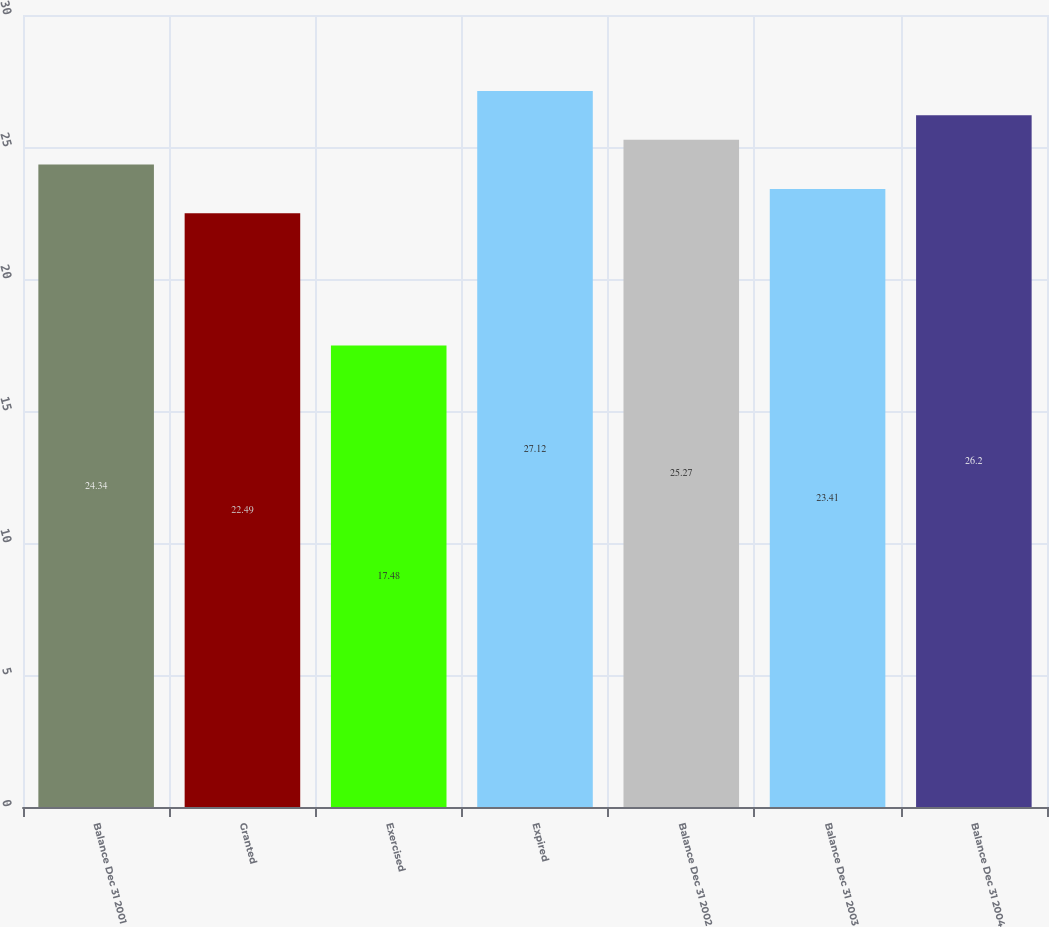Convert chart to OTSL. <chart><loc_0><loc_0><loc_500><loc_500><bar_chart><fcel>Balance Dec 31 2001<fcel>Granted<fcel>Exercised<fcel>Expired<fcel>Balance Dec 31 2002<fcel>Balance Dec 31 2003<fcel>Balance Dec 31 2004<nl><fcel>24.34<fcel>22.49<fcel>17.48<fcel>27.12<fcel>25.27<fcel>23.41<fcel>26.2<nl></chart> 